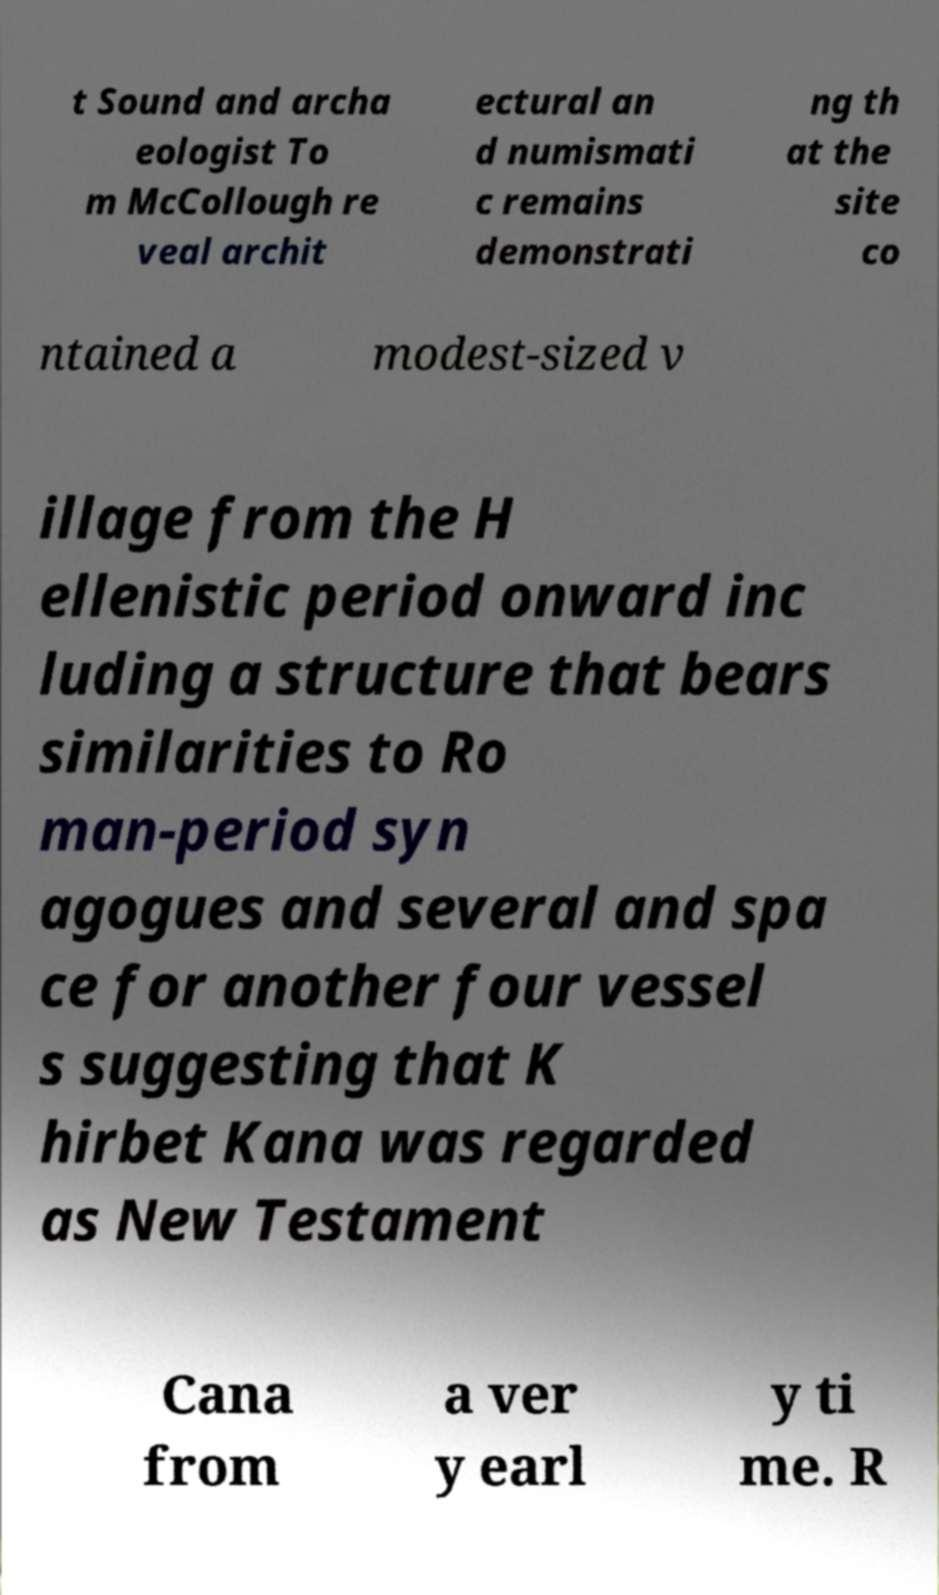Can you accurately transcribe the text from the provided image for me? t Sound and archa eologist To m McCollough re veal archit ectural an d numismati c remains demonstrati ng th at the site co ntained a modest-sized v illage from the H ellenistic period onward inc luding a structure that bears similarities to Ro man-period syn agogues and several and spa ce for another four vessel s suggesting that K hirbet Kana was regarded as New Testament Cana from a ver y earl y ti me. R 